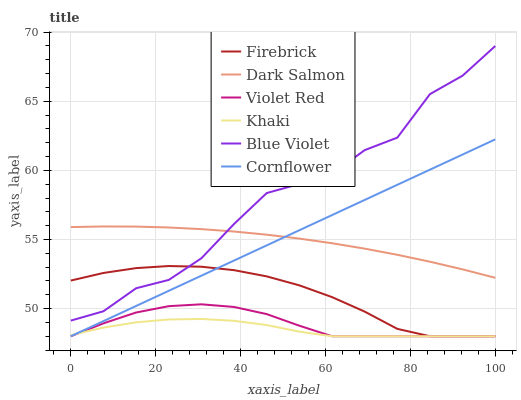Does Khaki have the minimum area under the curve?
Answer yes or no. Yes. Does Blue Violet have the maximum area under the curve?
Answer yes or no. Yes. Does Violet Red have the minimum area under the curve?
Answer yes or no. No. Does Violet Red have the maximum area under the curve?
Answer yes or no. No. Is Cornflower the smoothest?
Answer yes or no. Yes. Is Blue Violet the roughest?
Answer yes or no. Yes. Is Violet Red the smoothest?
Answer yes or no. No. Is Violet Red the roughest?
Answer yes or no. No. Does Cornflower have the lowest value?
Answer yes or no. Yes. Does Dark Salmon have the lowest value?
Answer yes or no. No. Does Blue Violet have the highest value?
Answer yes or no. Yes. Does Violet Red have the highest value?
Answer yes or no. No. Is Cornflower less than Blue Violet?
Answer yes or no. Yes. Is Blue Violet greater than Cornflower?
Answer yes or no. Yes. Does Firebrick intersect Blue Violet?
Answer yes or no. Yes. Is Firebrick less than Blue Violet?
Answer yes or no. No. Is Firebrick greater than Blue Violet?
Answer yes or no. No. Does Cornflower intersect Blue Violet?
Answer yes or no. No. 